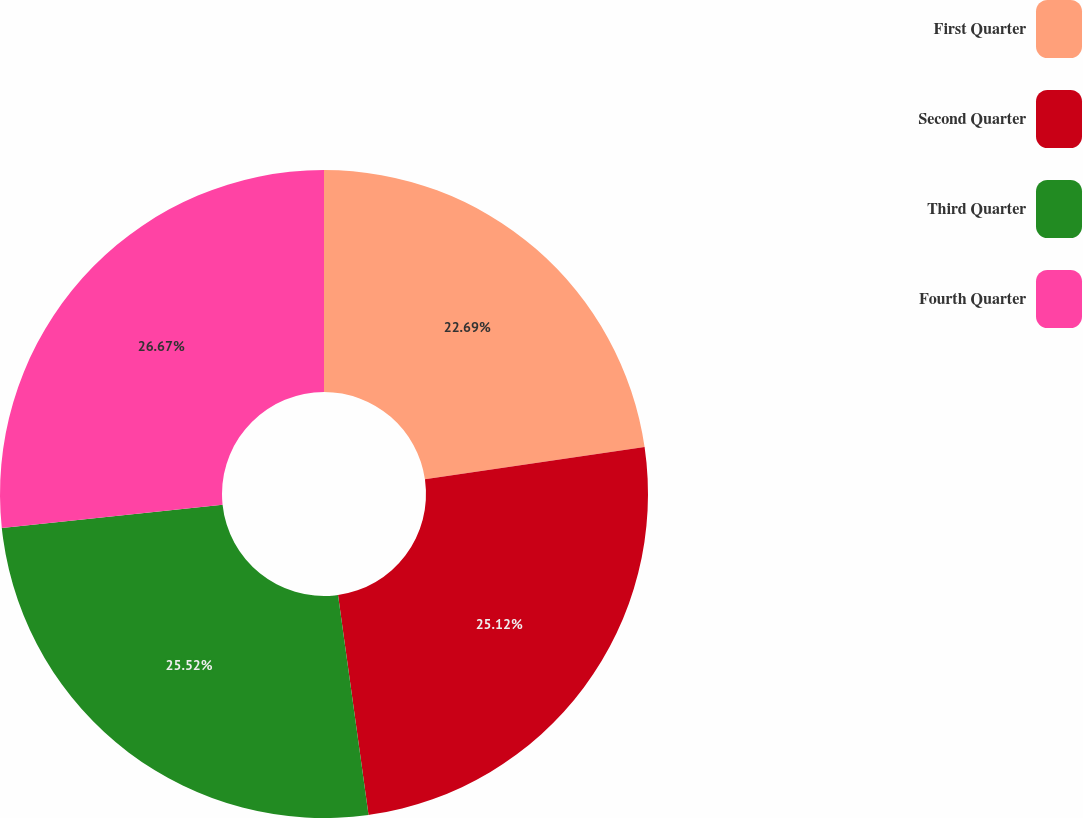Convert chart. <chart><loc_0><loc_0><loc_500><loc_500><pie_chart><fcel>First Quarter<fcel>Second Quarter<fcel>Third Quarter<fcel>Fourth Quarter<nl><fcel>22.69%<fcel>25.12%<fcel>25.52%<fcel>26.68%<nl></chart> 